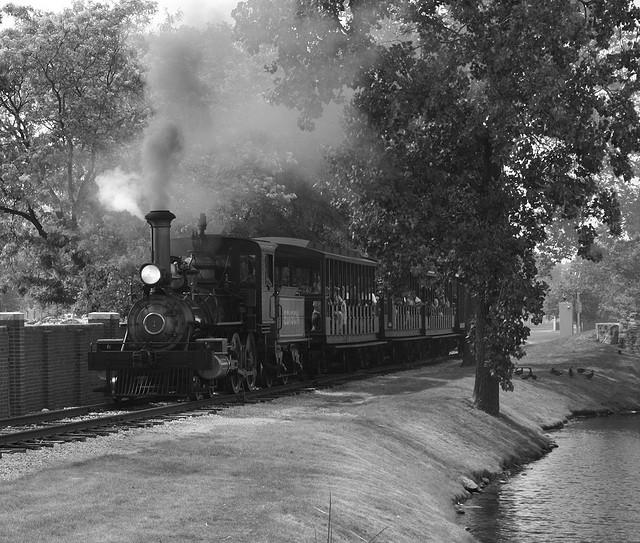Is this picture in black and white?
Quick response, please. Yes. What kind of animal is standing by the pond?
Keep it brief. Duck. Is this an electric train?
Be succinct. No. 